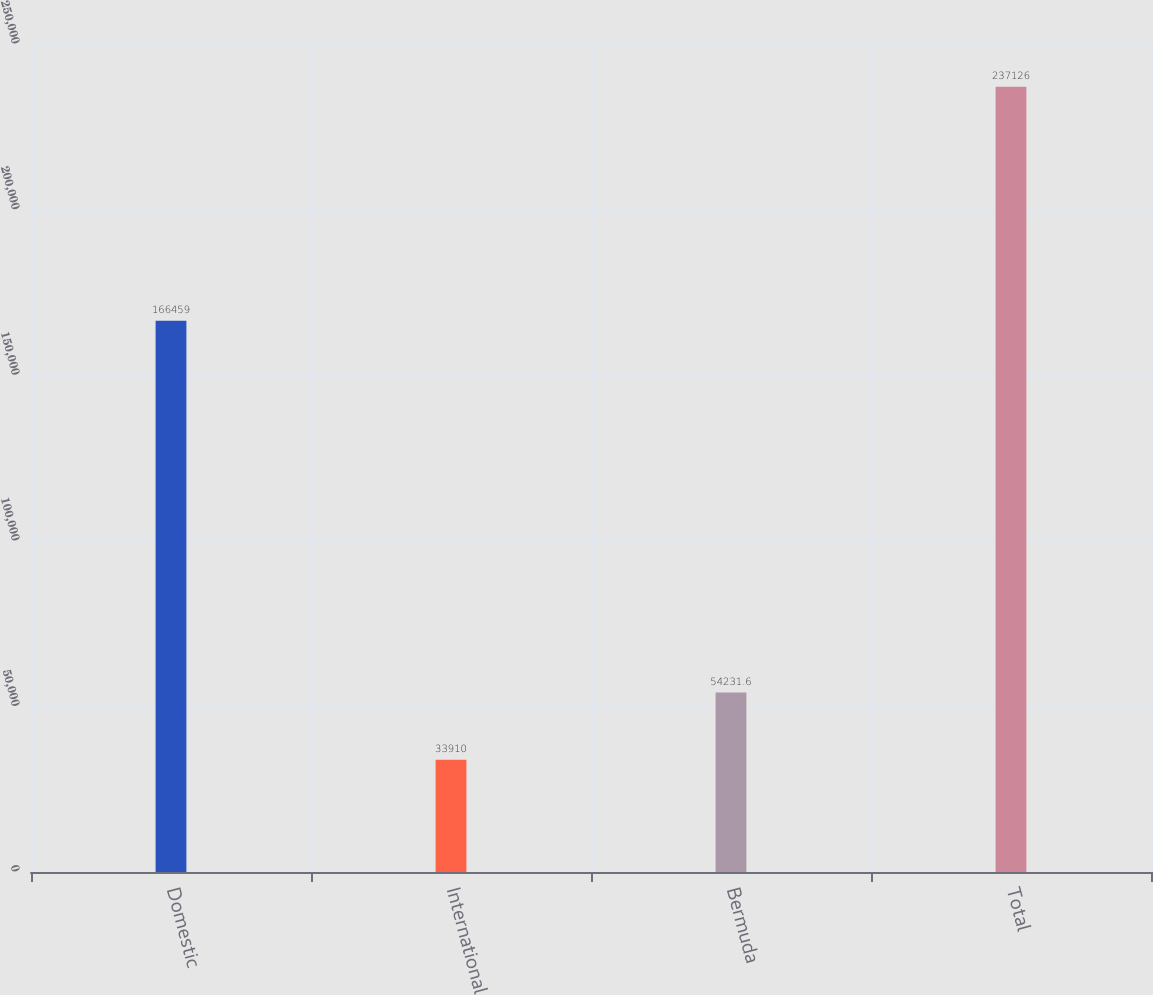Convert chart. <chart><loc_0><loc_0><loc_500><loc_500><bar_chart><fcel>Domestic<fcel>International<fcel>Bermuda<fcel>Total<nl><fcel>166459<fcel>33910<fcel>54231.6<fcel>237126<nl></chart> 